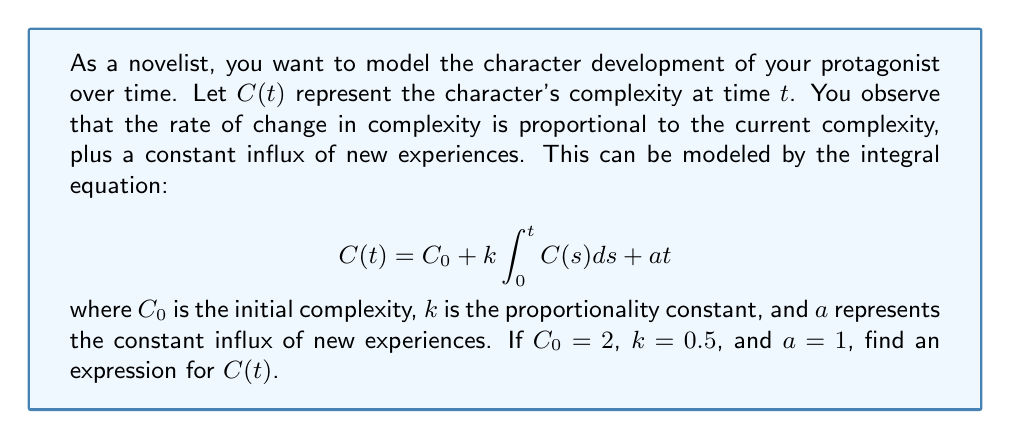What is the answer to this math problem? To solve this integral equation, we'll follow these steps:

1) First, differentiate both sides of the equation with respect to $t$:
   $$\frac{dC}{dt} = k C(t) + a$$

2) This is now a first-order linear differential equation. We can solve it using the integrating factor method.

3) The integrating factor is $e^{-kt}$. Multiply both sides by this:
   $$e^{-kt}\frac{dC}{dt} - ke^{-kt}C = ae^{-kt}$$

4) The left side is now the derivative of $e^{-kt}C$. So we can write:
   $$\frac{d}{dt}(e^{-kt}C) = ae^{-kt}$$

5) Integrate both sides:
   $$e^{-kt}C = -\frac{a}{k}e^{-kt} + B$$
   where $B$ is a constant of integration.

6) Solve for $C(t)$:
   $$C(t) = -\frac{a}{k} + Be^{kt}$$

7) Use the initial condition $C(0) = C_0 = 2$ to find $B$:
   $$2 = -\frac{a}{k} + B$$
   $$B = 2 + \frac{a}{k}$$

8) Substitute this back into the equation for $C(t)$:
   $$C(t) = -\frac{a}{k} + (2 + \frac{a}{k})e^{kt}$$

9) Now substitute the given values $k = 0.5$, $a = 1$:
   $$C(t) = -2 + 4e^{0.5t}$$

This is the final expression for $C(t)$.
Answer: $C(t) = -2 + 4e^{0.5t}$ 